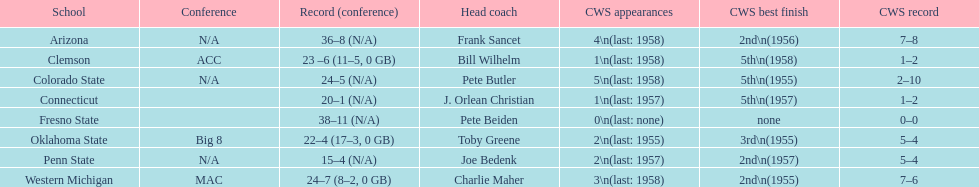At which school have there been no appearances in the college world series? Fresno State. 